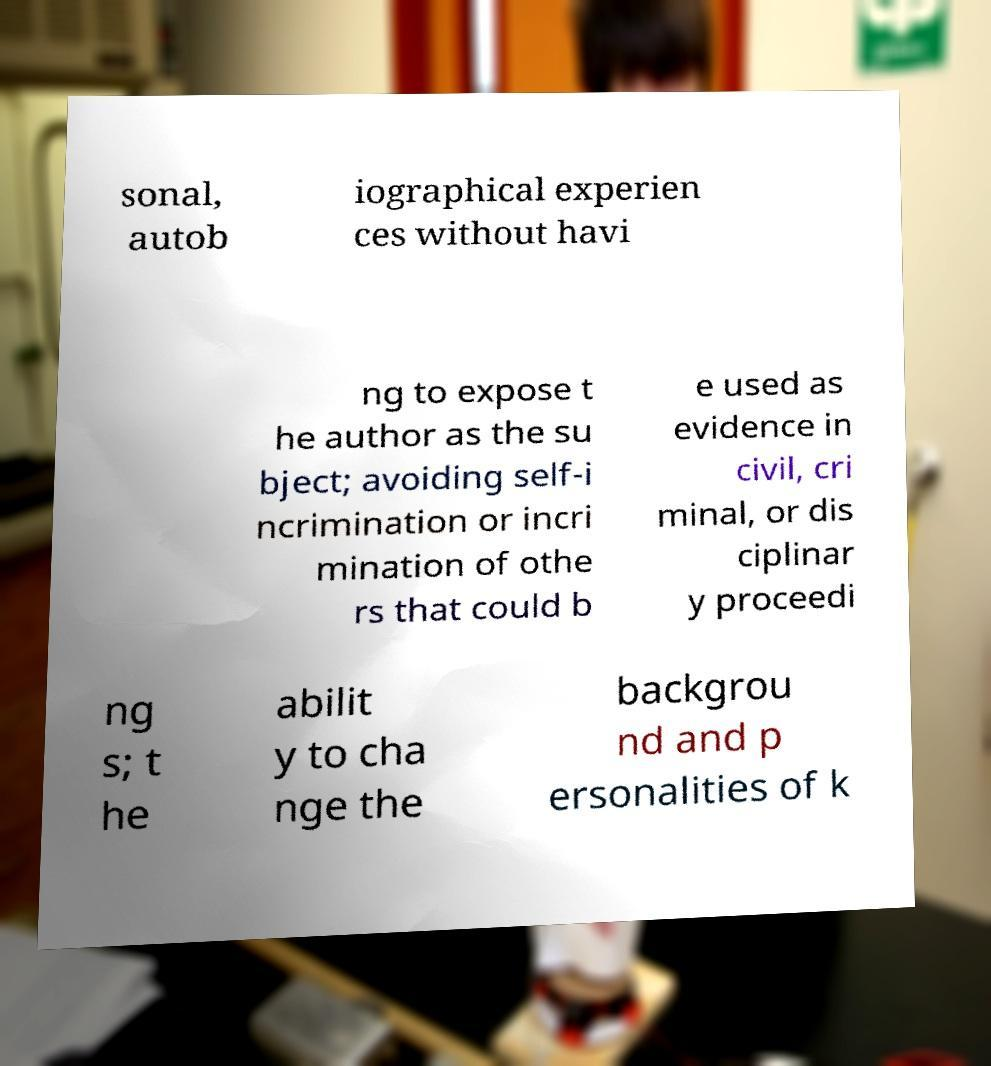What messages or text are displayed in this image? I need them in a readable, typed format. sonal, autob iographical experien ces without havi ng to expose t he author as the su bject; avoiding self-i ncrimination or incri mination of othe rs that could b e used as evidence in civil, cri minal, or dis ciplinar y proceedi ng s; t he abilit y to cha nge the backgrou nd and p ersonalities of k 